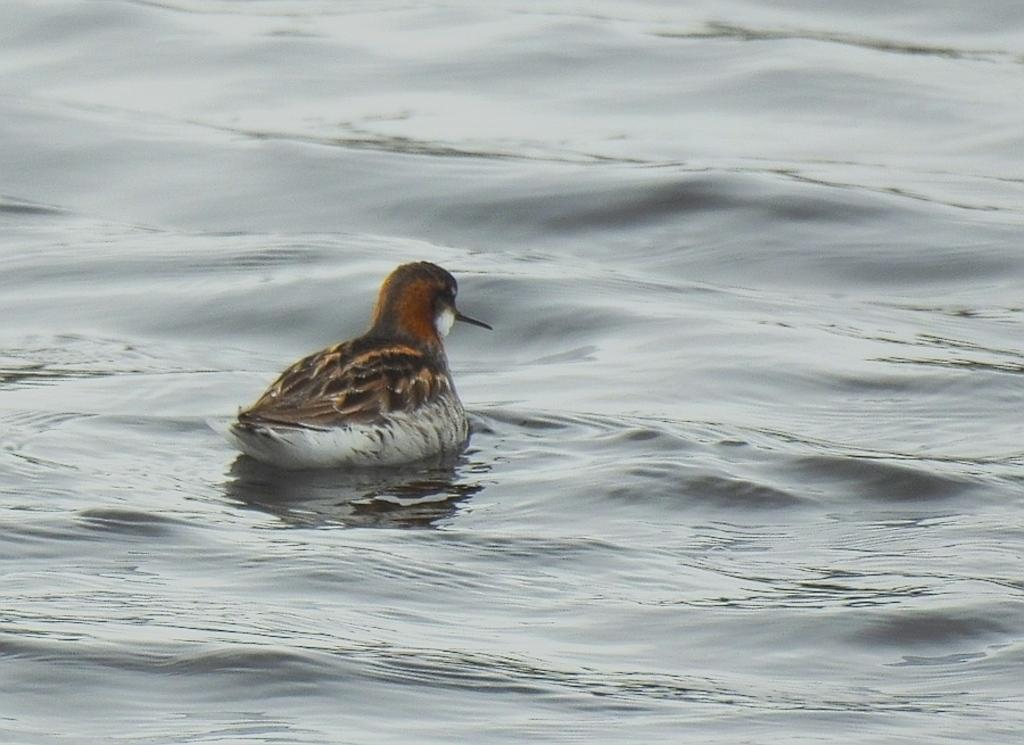What type of animal is in the image? There is a bird in the image. What colors can be seen on the bird? The bird is in brown, black, and white colors. Where is the bird located in the image? The bird is in the water. What type of curtain can be seen hanging in the water in the image? There is no curtain present in the image; it features a bird in the water. How many fish are visible swimming with the bird in the image? There are no fish visible in the image; it only features a bird in the water. 